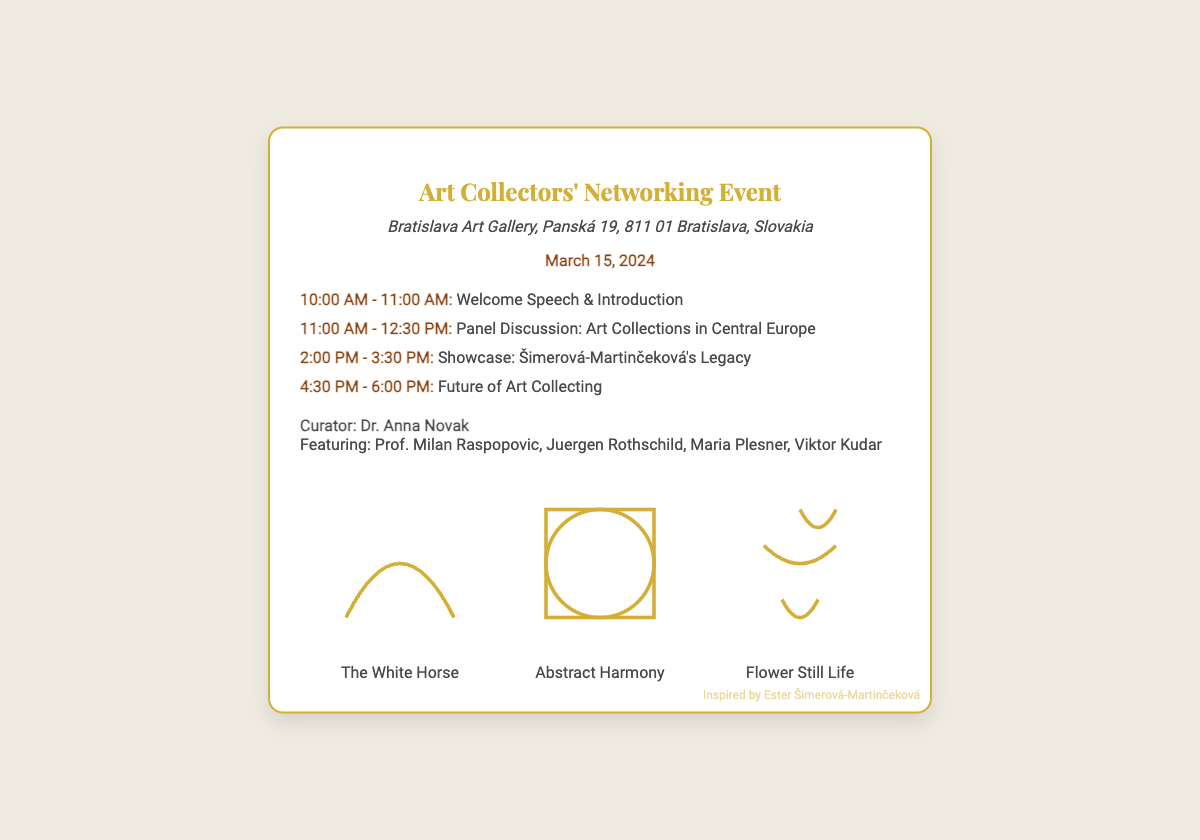What is the venue name? The venue name is directly stated in the document as "Bratislava Art Gallery".
Answer: Bratislava Art Gallery What date is the event scheduled? The date of the event is clearly specified in the document.
Answer: March 15, 2024 Who is the curator for the event? The curator's name is mentioned in the participants section.
Answer: Dr. Anna Novak How many schedule items are listed? The number of schedule items can be counted from the schedule section of the document.
Answer: Four What time does the panel discussion begin? The starting time for the panel discussion is indicated in the schedule.
Answer: 11:00 AM Which painting is included in the art illustrations labeled "The White Horse"? The painting's name can be found directly next to its illustration in the document.
Answer: The White Horse What is the main topic of the 2 PM showcase? The main topic is described in the schedule for the 2 PM event.
Answer: Šimerová-Martinčeková's Legacy Name one of the featured participants. One of the featured participants is listed in the participants section.
Answer: Prof. Milan Raspopovic What color is used for the business card's border? The color used for the border is specified within the style of the document.
Answer: Gold 